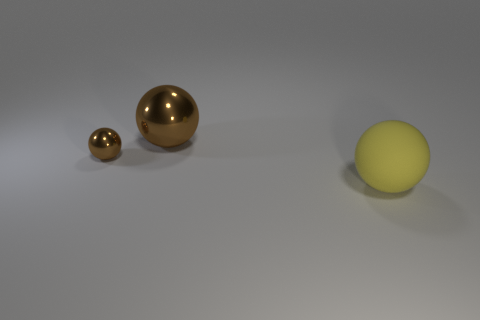There is a large rubber thing that is the same shape as the big brown metallic object; what is its color?
Your response must be concise. Yellow. There is a metal object that is in front of the big sphere that is behind the big yellow sphere; what color is it?
Offer a terse response. Brown. The yellow object that is the same shape as the big brown object is what size?
Keep it short and to the point. Large. How many other objects are made of the same material as the tiny object?
Your response must be concise. 1. There is a small brown metallic object in front of the big metallic ball; how many large brown objects are to the right of it?
Your answer should be compact. 1. Are there any metallic spheres on the right side of the tiny metallic sphere?
Keep it short and to the point. Yes. There is a yellow thing to the right of the large brown thing; is its shape the same as the tiny thing?
Ensure brevity in your answer.  Yes. What is the material of the thing that is the same color as the small shiny sphere?
Ensure brevity in your answer.  Metal. How many other metal things are the same color as the small metallic object?
Ensure brevity in your answer.  1. Is there another brown object that has the same shape as the tiny brown metallic object?
Provide a succinct answer. Yes. 